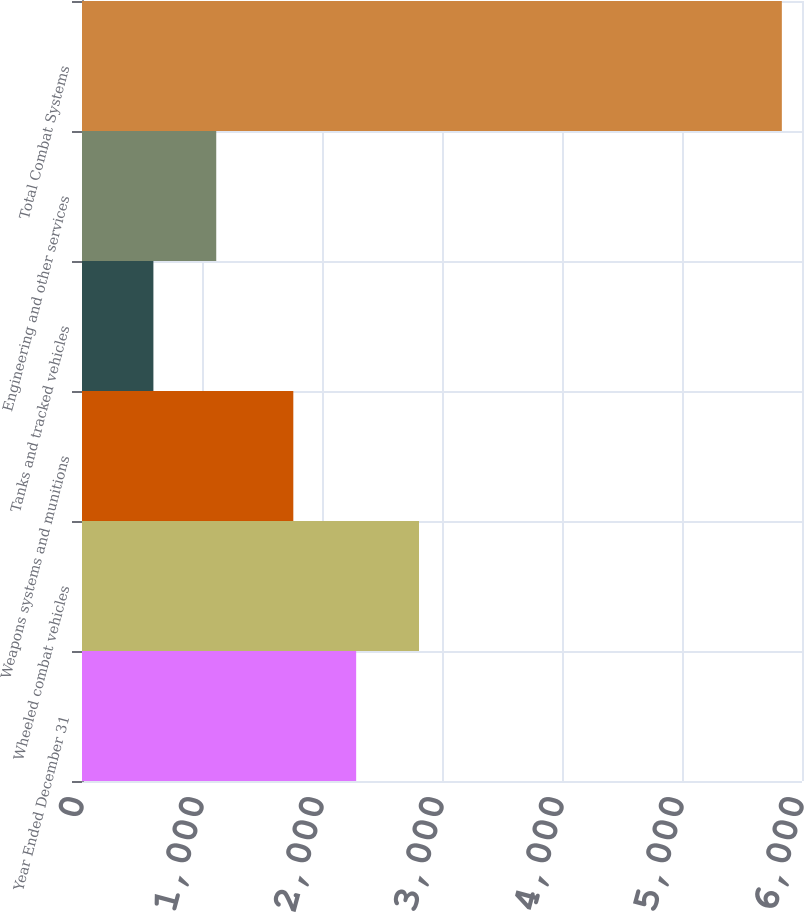Convert chart to OTSL. <chart><loc_0><loc_0><loc_500><loc_500><bar_chart><fcel>Year Ended December 31<fcel>Wheeled combat vehicles<fcel>Weapons systems and munitions<fcel>Tanks and tracked vehicles<fcel>Engineering and other services<fcel>Total Combat Systems<nl><fcel>2284.7<fcel>2808.4<fcel>1761<fcel>595<fcel>1118.7<fcel>5832<nl></chart> 